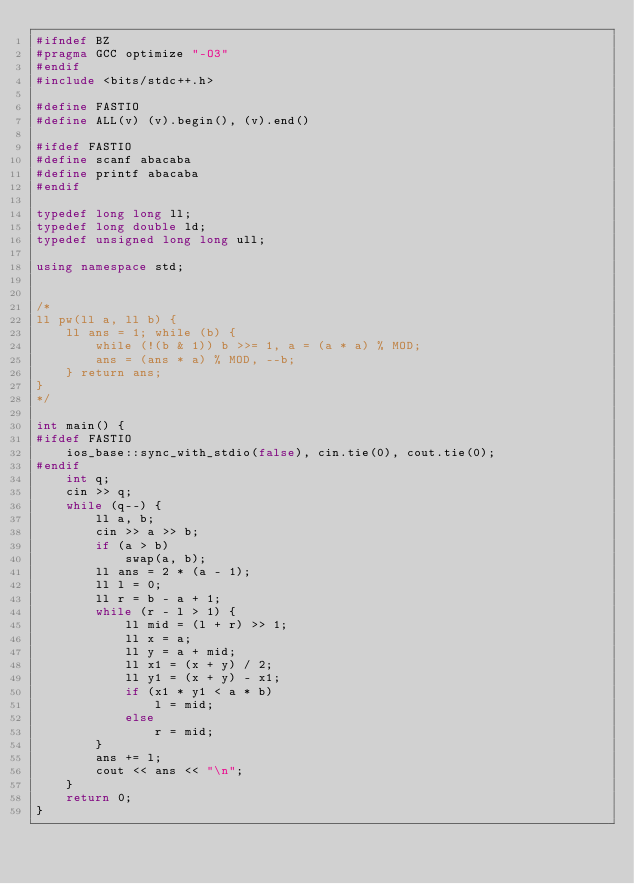<code> <loc_0><loc_0><loc_500><loc_500><_C++_>#ifndef BZ
#pragma GCC optimize "-O3"
#endif
#include <bits/stdc++.h>

#define FASTIO
#define ALL(v) (v).begin(), (v).end()

#ifdef FASTIO
#define scanf abacaba
#define printf abacaba
#endif

typedef long long ll;
typedef long double ld;
typedef unsigned long long ull;

using namespace std;


/*
ll pw(ll a, ll b) {
	ll ans = 1; while (b) {
		while (!(b & 1)) b >>= 1, a = (a * a) % MOD;
		ans = (ans * a) % MOD, --b;
	} return ans;
}
*/

int main() {
#ifdef FASTIO
	ios_base::sync_with_stdio(false), cin.tie(0), cout.tie(0);
#endif
	int q;
	cin >> q;
	while (q--) {
		ll a, b;
		cin >> a >> b;
		if (a > b)
			swap(a, b);
		ll ans = 2 * (a - 1);
		ll l = 0;
		ll r = b - a + 1;
		while (r - l > 1) {
			ll mid = (l + r) >> 1;
			ll x = a;
			ll y = a + mid;
			ll x1 = (x + y) / 2;
			ll y1 = (x + y) - x1;
			if (x1 * y1 < a * b)
				l = mid;
			else
				r = mid;
		}
		ans += l;
		cout << ans << "\n";
	}
	return 0;
}

</code> 